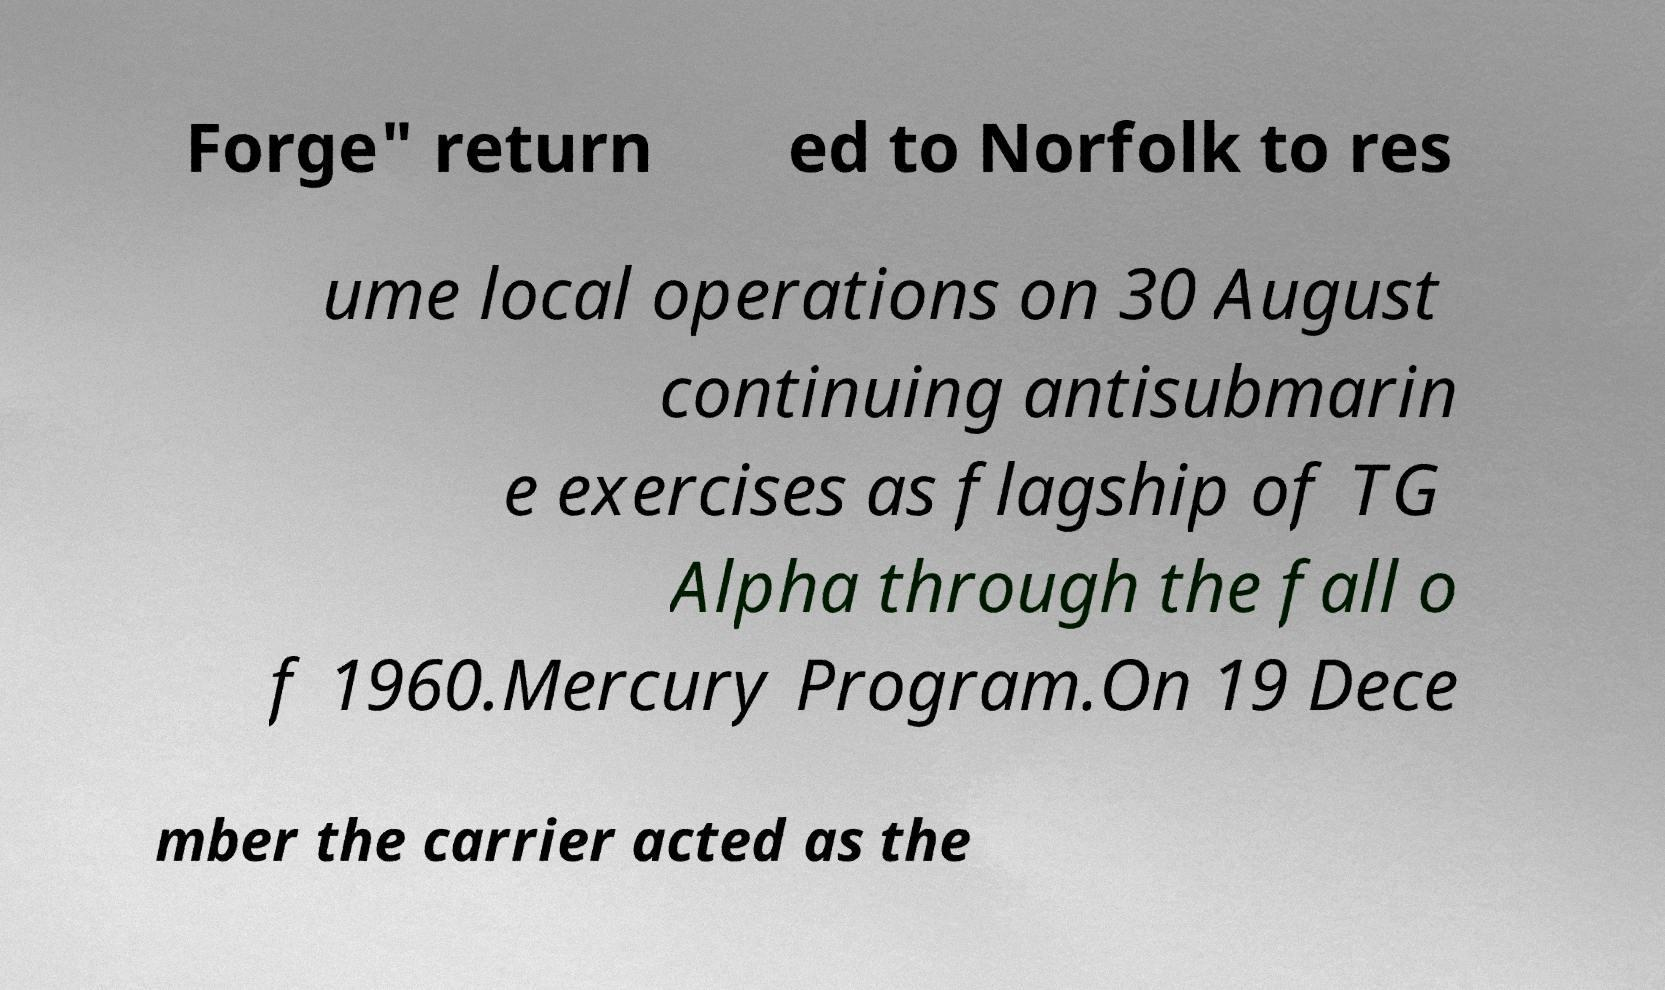Can you accurately transcribe the text from the provided image for me? Forge" return ed to Norfolk to res ume local operations on 30 August continuing antisubmarin e exercises as flagship of TG Alpha through the fall o f 1960.Mercury Program.On 19 Dece mber the carrier acted as the 